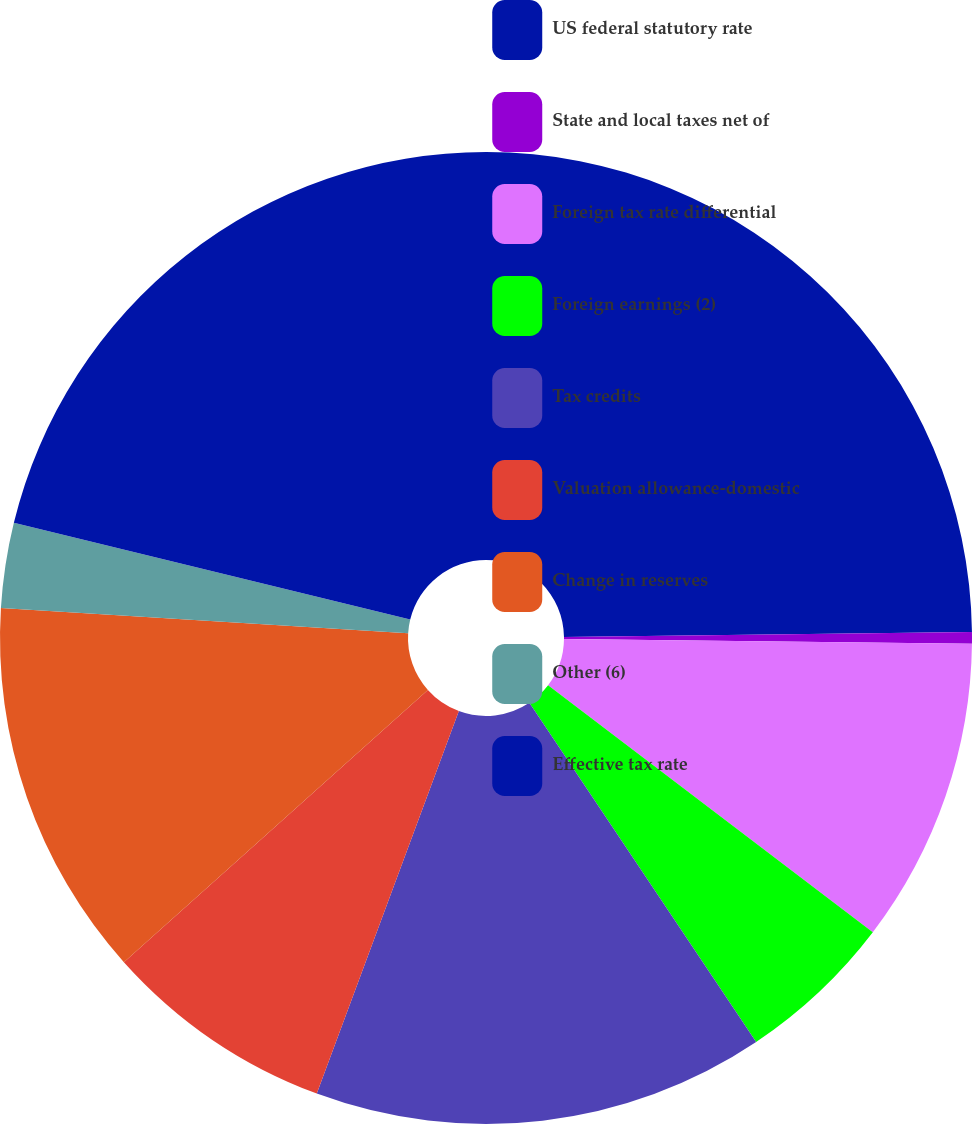Convert chart. <chart><loc_0><loc_0><loc_500><loc_500><pie_chart><fcel>US federal statutory rate<fcel>State and local taxes net of<fcel>Foreign tax rate differential<fcel>Foreign earnings (2)<fcel>Tax credits<fcel>Valuation allowance-domestic<fcel>Change in reserves<fcel>Other (6)<fcel>Effective tax rate<nl><fcel>24.8%<fcel>0.39%<fcel>10.16%<fcel>5.27%<fcel>15.04%<fcel>7.72%<fcel>12.6%<fcel>2.83%<fcel>21.19%<nl></chart> 